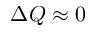Convert formula to latex. <formula><loc_0><loc_0><loc_500><loc_500>\Delta Q \approx 0</formula> 